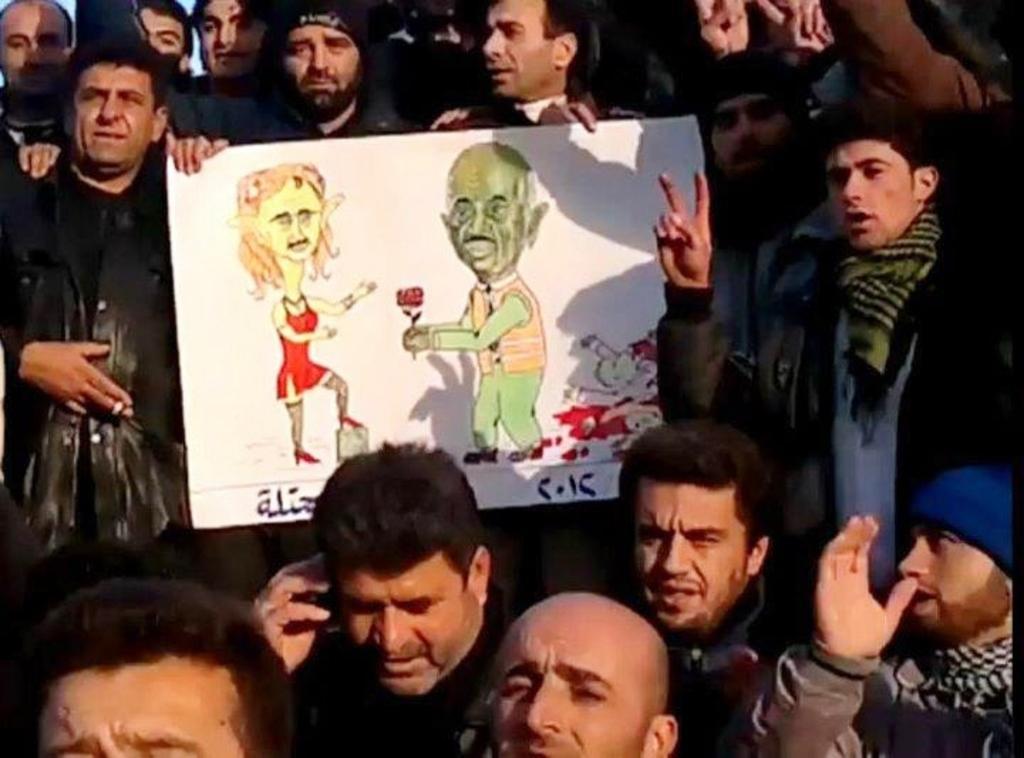In one or two sentences, can you explain what this image depicts? In this picture, we see many people standing. The man in black jacket is holding a whiteboard with some sketch drawn on it. On the left side, the man in black jacket is holding a cigarette in his hand. This picture might be clicked outside the city. It is a sunny day. 